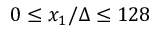Convert formula to latex. <formula><loc_0><loc_0><loc_500><loc_500>0 \leq x _ { 1 } / \Delta \leq 1 2 8</formula> 